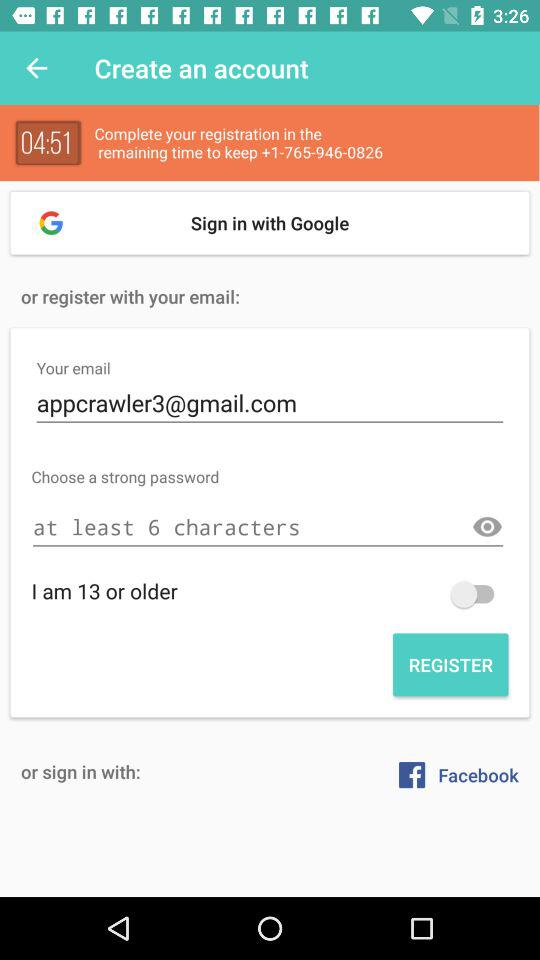What is the status of "I am 13 or older"? The status is "off". 